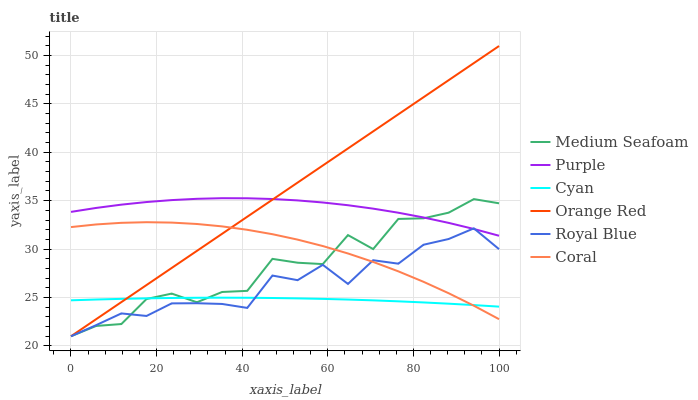Does Cyan have the minimum area under the curve?
Answer yes or no. Yes. Does Orange Red have the maximum area under the curve?
Answer yes or no. Yes. Does Coral have the minimum area under the curve?
Answer yes or no. No. Does Coral have the maximum area under the curve?
Answer yes or no. No. Is Orange Red the smoothest?
Answer yes or no. Yes. Is Medium Seafoam the roughest?
Answer yes or no. Yes. Is Coral the smoothest?
Answer yes or no. No. Is Coral the roughest?
Answer yes or no. No. Does Orange Red have the lowest value?
Answer yes or no. Yes. Does Coral have the lowest value?
Answer yes or no. No. Does Orange Red have the highest value?
Answer yes or no. Yes. Does Coral have the highest value?
Answer yes or no. No. Is Cyan less than Purple?
Answer yes or no. Yes. Is Purple greater than Cyan?
Answer yes or no. Yes. Does Cyan intersect Royal Blue?
Answer yes or no. Yes. Is Cyan less than Royal Blue?
Answer yes or no. No. Is Cyan greater than Royal Blue?
Answer yes or no. No. Does Cyan intersect Purple?
Answer yes or no. No. 